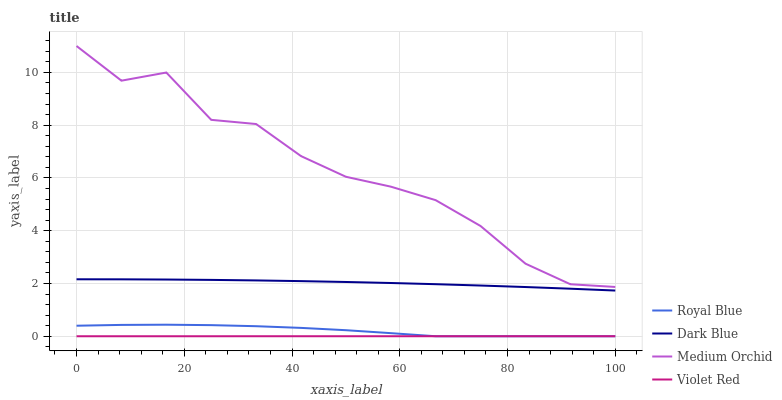Does Violet Red have the minimum area under the curve?
Answer yes or no. Yes. Does Medium Orchid have the maximum area under the curve?
Answer yes or no. Yes. Does Medium Orchid have the minimum area under the curve?
Answer yes or no. No. Does Violet Red have the maximum area under the curve?
Answer yes or no. No. Is Violet Red the smoothest?
Answer yes or no. Yes. Is Medium Orchid the roughest?
Answer yes or no. Yes. Is Medium Orchid the smoothest?
Answer yes or no. No. Is Violet Red the roughest?
Answer yes or no. No. Does Royal Blue have the lowest value?
Answer yes or no. Yes. Does Medium Orchid have the lowest value?
Answer yes or no. No. Does Medium Orchid have the highest value?
Answer yes or no. Yes. Does Violet Red have the highest value?
Answer yes or no. No. Is Dark Blue less than Medium Orchid?
Answer yes or no. Yes. Is Medium Orchid greater than Violet Red?
Answer yes or no. Yes. Does Violet Red intersect Royal Blue?
Answer yes or no. Yes. Is Violet Red less than Royal Blue?
Answer yes or no. No. Is Violet Red greater than Royal Blue?
Answer yes or no. No. Does Dark Blue intersect Medium Orchid?
Answer yes or no. No. 